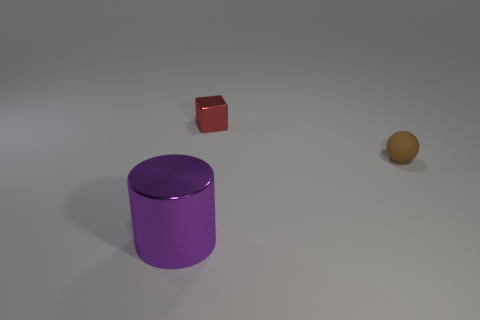Add 2 tiny brown balls. How many objects exist? 5 Subtract all cubes. How many objects are left? 2 Subtract 1 cylinders. How many cylinders are left? 0 Subtract all gray cubes. How many green spheres are left? 0 Subtract all small brown spheres. Subtract all tiny balls. How many objects are left? 1 Add 1 tiny red things. How many tiny red things are left? 2 Add 2 brown things. How many brown things exist? 3 Subtract 0 brown cylinders. How many objects are left? 3 